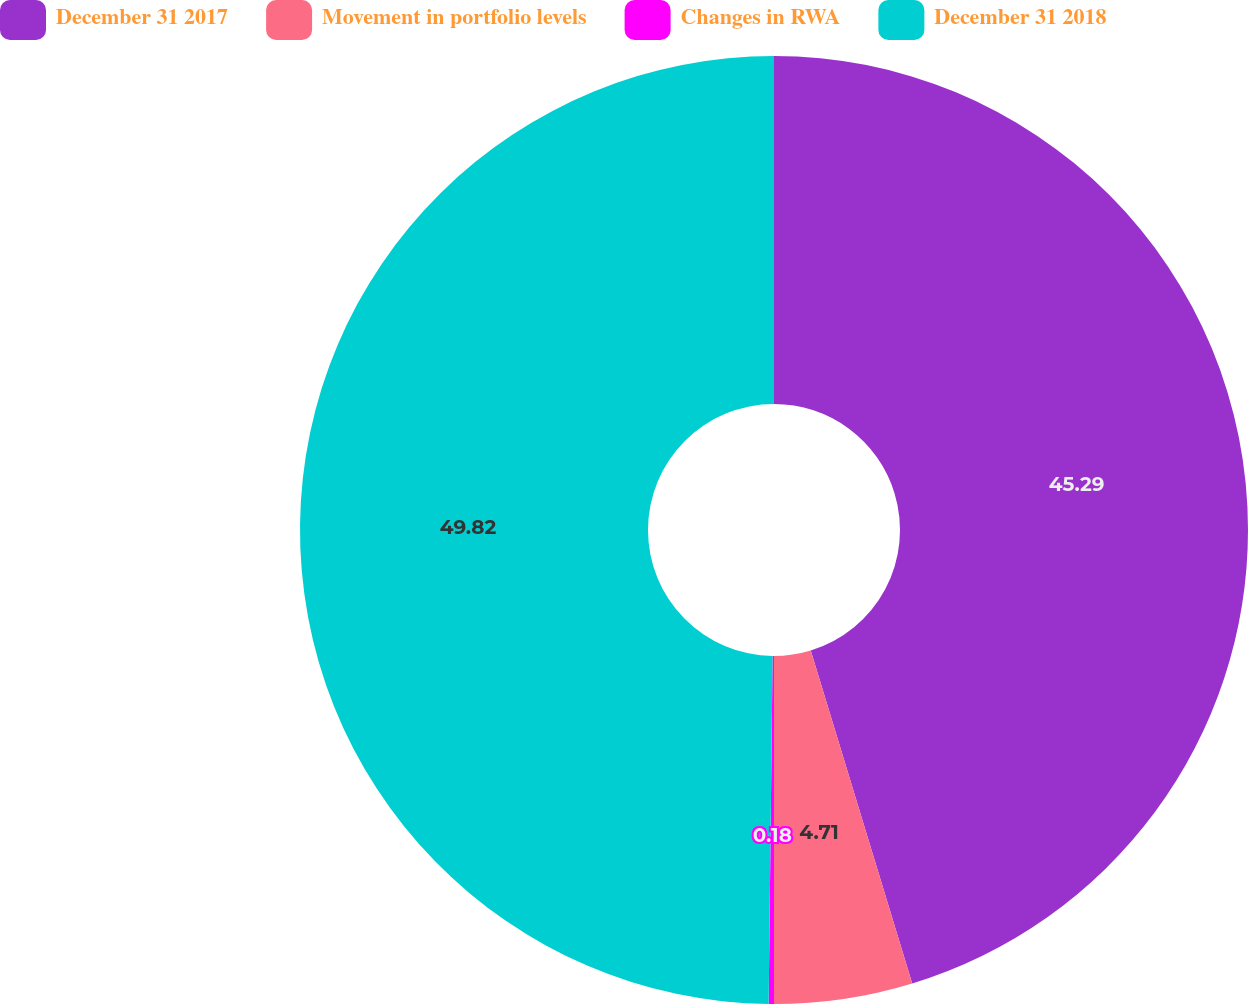Convert chart. <chart><loc_0><loc_0><loc_500><loc_500><pie_chart><fcel>December 31 2017<fcel>Movement in portfolio levels<fcel>Changes in RWA<fcel>December 31 2018<nl><fcel>45.29%<fcel>4.71%<fcel>0.18%<fcel>49.82%<nl></chart> 